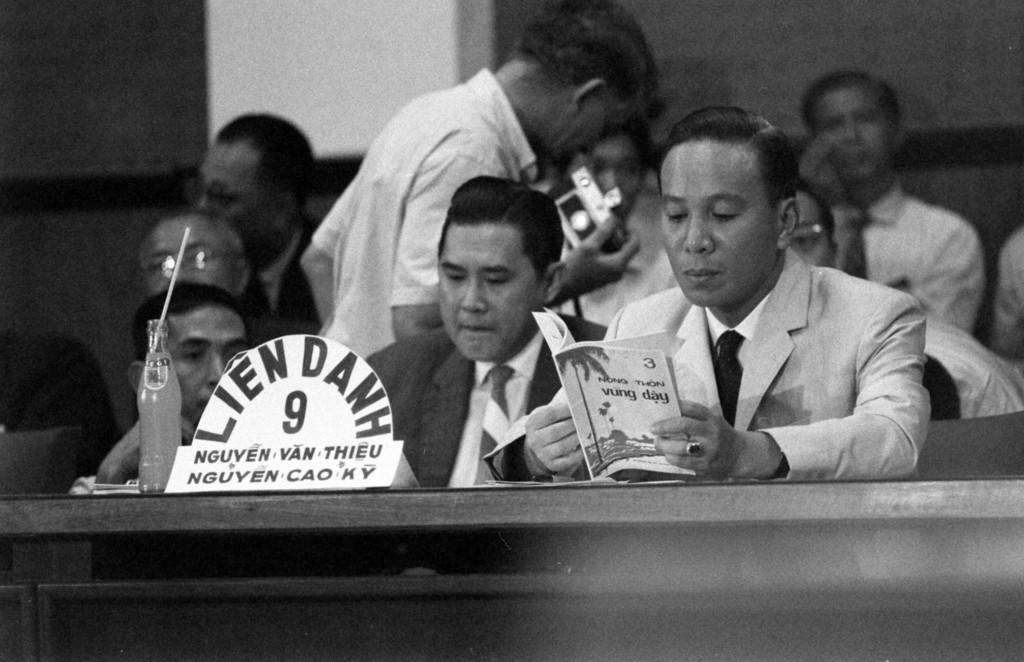Describe this image in one or two sentences. Here people are sitting and a person is reading the book. There is a cool drink bottle at here. 